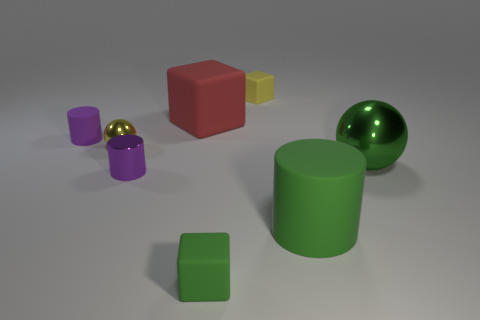Subtract all large matte cylinders. How many cylinders are left? 2 Subtract all red cubes. How many cubes are left? 2 Subtract all cylinders. How many objects are left? 5 Add 1 green matte objects. How many objects exist? 9 Subtract 0 purple balls. How many objects are left? 8 Subtract 2 spheres. How many spheres are left? 0 Subtract all purple cylinders. Subtract all brown cubes. How many cylinders are left? 1 Subtract all green spheres. How many cyan blocks are left? 0 Subtract all small purple metallic cylinders. Subtract all rubber cubes. How many objects are left? 4 Add 7 small cubes. How many small cubes are left? 9 